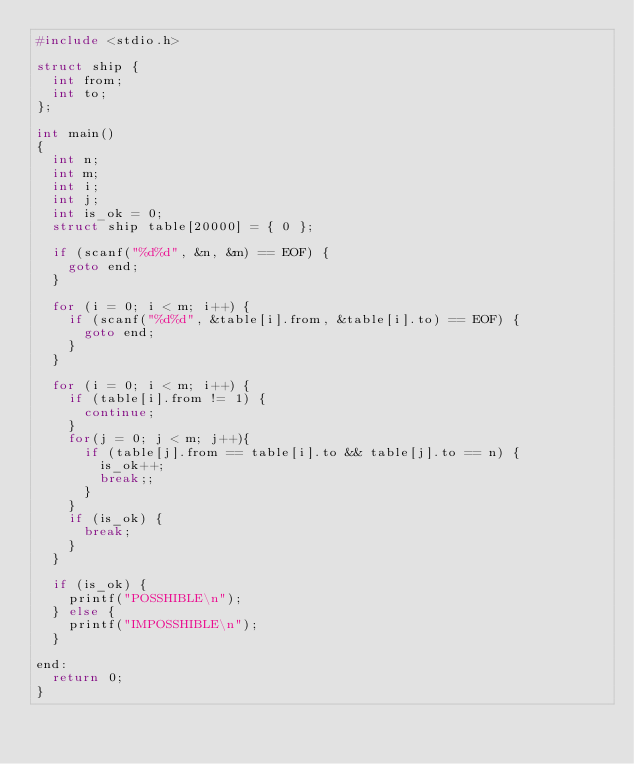<code> <loc_0><loc_0><loc_500><loc_500><_C_>#include <stdio.h>

struct ship {
	int from;
	int to;
};

int main()
{
	int n;
	int m;
	int i;
	int j;
	int is_ok = 0;
	struct ship table[20000] = { 0 };
	
	if (scanf("%d%d", &n, &m) == EOF) {
		goto end;
	}
	
	for (i = 0; i < m; i++) {
		if (scanf("%d%d", &table[i].from, &table[i].to) == EOF) {
			goto end;
		}
	}
	
	for (i = 0; i < m; i++) {
		if (table[i].from != 1) {
			continue;
		}
		for(j = 0; j < m; j++){
			if (table[j].from == table[i].to && table[j].to == n) {
				is_ok++;
				break;;
			}
		}
		if (is_ok) {
			break;
		}
	}
	
	if (is_ok) {
		printf("POSSHIBLE\n");
	} else {
		printf("IMPOSSHIBLE\n");
	}

end:
	return 0;
}
</code> 